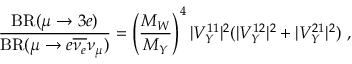Convert formula to latex. <formula><loc_0><loc_0><loc_500><loc_500>{ \frac { B R ( \mu \to 3 e ) } { B R ( \mu \to e \overline { { { \nu _ { e } } } } \nu _ { \mu } ) } } = \left ( \frac { M _ { W } } { M _ { Y } } \right ) ^ { 4 } | V _ { Y } ^ { 1 1 } | ^ { 2 } ( | V _ { Y } ^ { 1 2 } | ^ { 2 } + | V _ { Y } ^ { 2 1 } | ^ { 2 } ) \ ,</formula> 